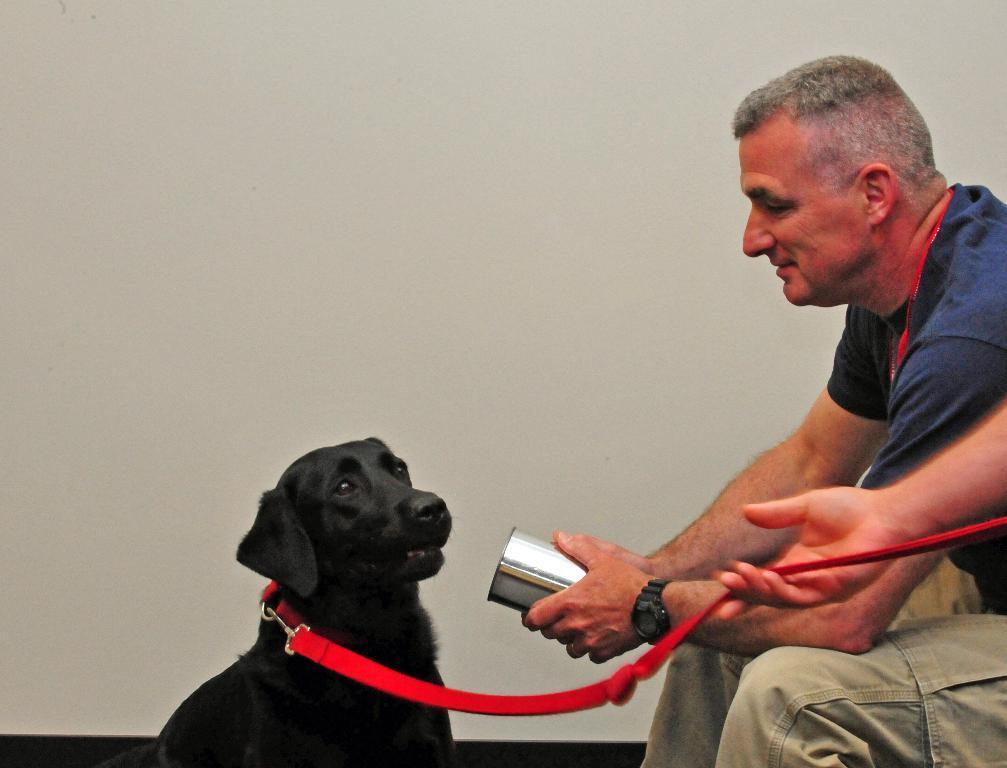Please provide a concise description of this image. In this image I can see a person is holding something. I can see a black dog and red color belt. Background is in white color. 